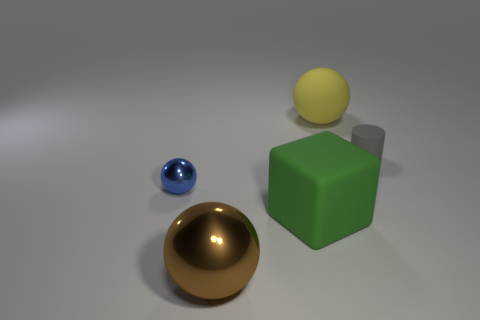Add 3 large blue rubber balls. How many objects exist? 8 Subtract all blocks. How many objects are left? 4 Add 5 metal blocks. How many metal blocks exist? 5 Subtract 0 brown cylinders. How many objects are left? 5 Subtract all purple rubber spheres. Subtract all large rubber spheres. How many objects are left? 4 Add 5 large rubber spheres. How many large rubber spheres are left? 6 